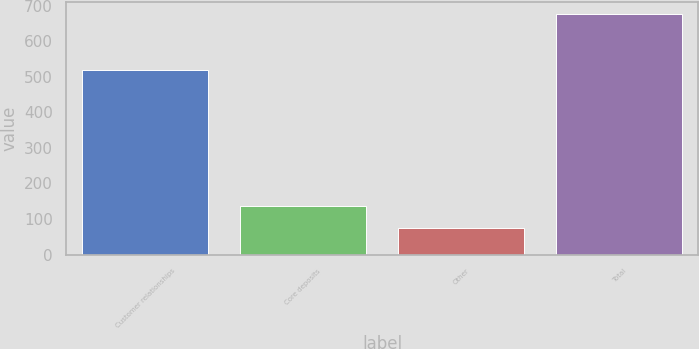<chart> <loc_0><loc_0><loc_500><loc_500><bar_chart><fcel>Customer relationships<fcel>Core deposits<fcel>Other<fcel>Total<nl><fcel>520<fcel>135.3<fcel>75<fcel>678<nl></chart> 